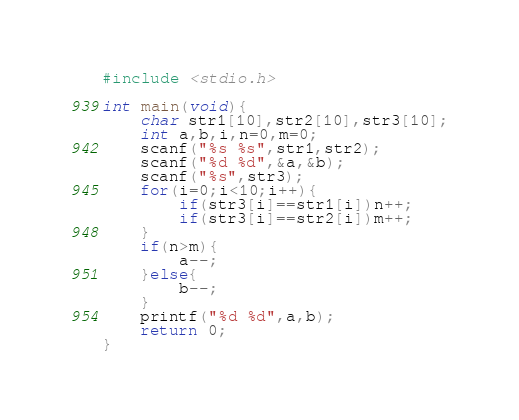<code> <loc_0><loc_0><loc_500><loc_500><_C_>#include <stdio.h>

int main(void){
    char str1[10],str2[10],str3[10];
    int a,b,i,n=0,m=0;
    scanf("%s %s",str1,str2);
    scanf("%d %d",&a,&b);
    scanf("%s",str3);
    for(i=0;i<10;i++){
        if(str3[i]==str1[i])n++;
        if(str3[i]==str2[i])m++;
    }
    if(n>m){
        a--;
    }else{
        b--;
    }
    printf("%d %d",a,b);
    return 0;
}</code> 